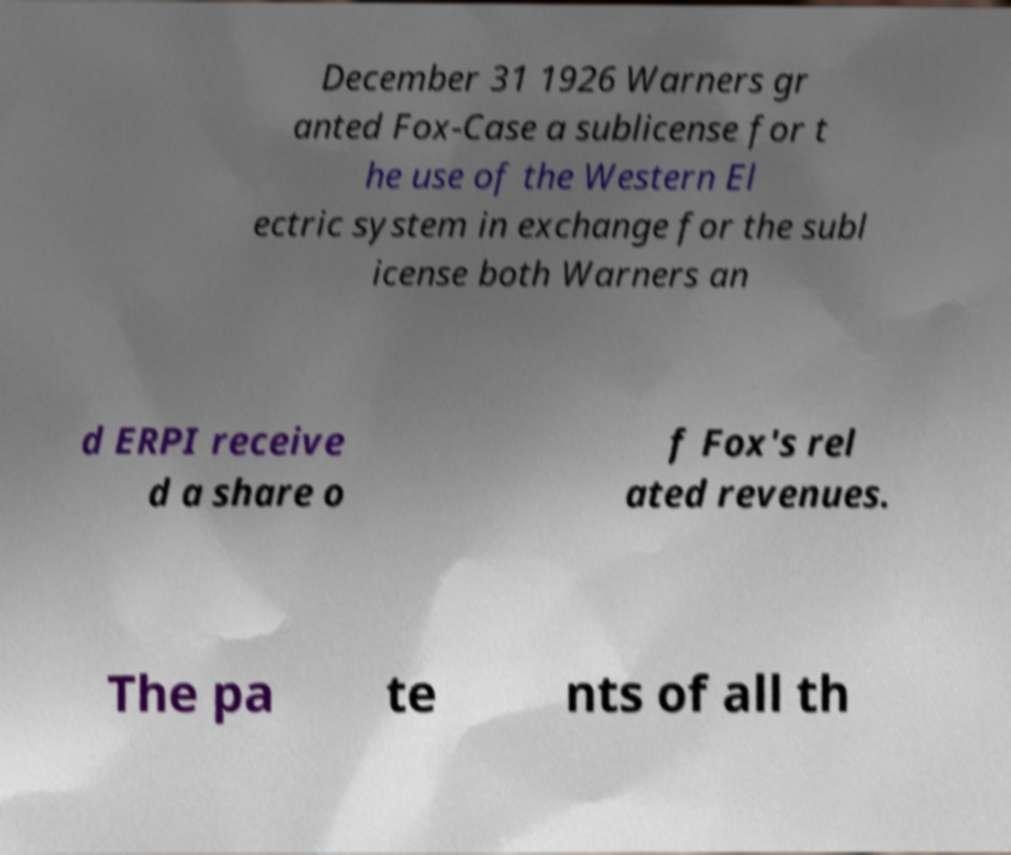There's text embedded in this image that I need extracted. Can you transcribe it verbatim? December 31 1926 Warners gr anted Fox-Case a sublicense for t he use of the Western El ectric system in exchange for the subl icense both Warners an d ERPI receive d a share o f Fox's rel ated revenues. The pa te nts of all th 